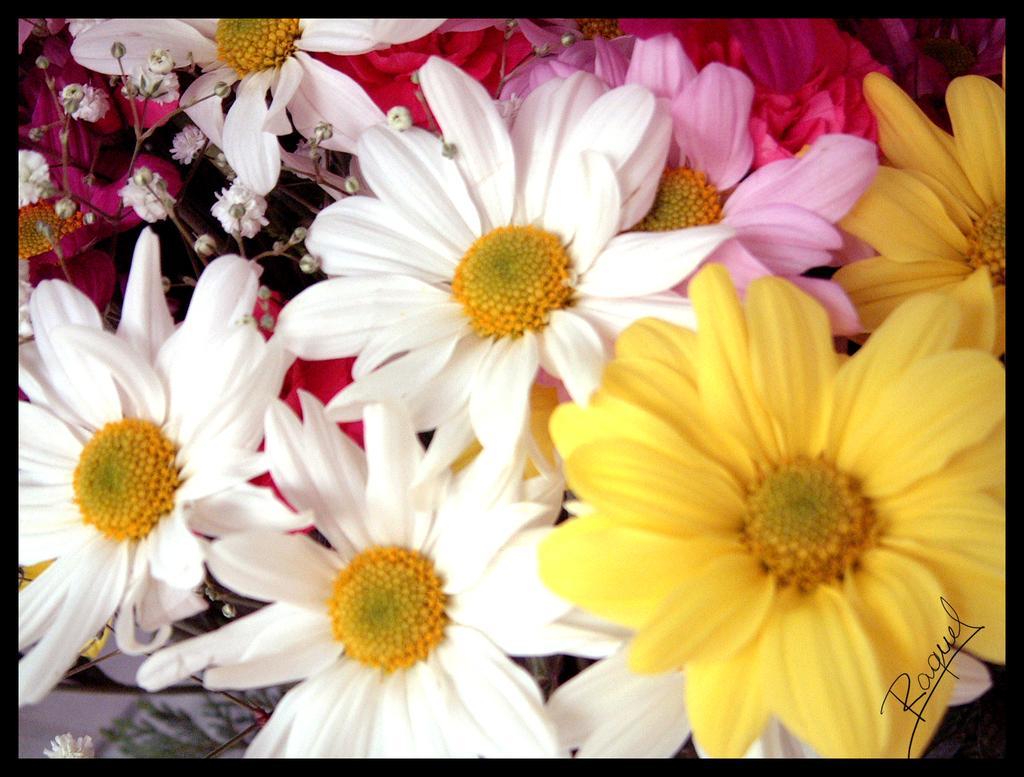Could you give a brief overview of what you see in this image? In the image we can see some flowers. 